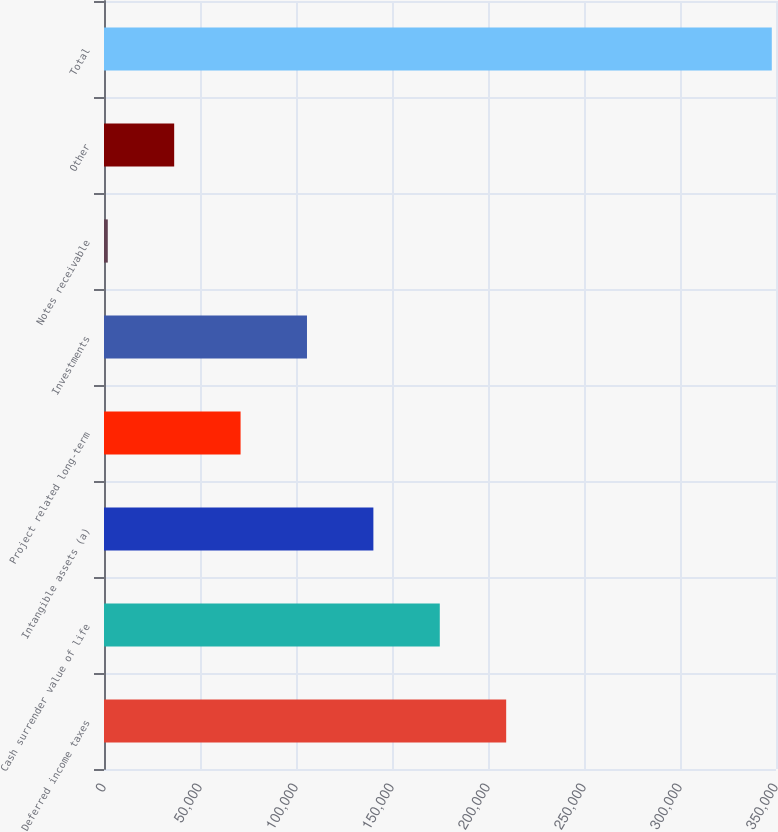Convert chart. <chart><loc_0><loc_0><loc_500><loc_500><bar_chart><fcel>Deferred income taxes<fcel>Cash surrender value of life<fcel>Intangible assets (a)<fcel>Project related long-term<fcel>Investments<fcel>Notes receivable<fcel>Other<fcel>Total<nl><fcel>209470<fcel>174886<fcel>140303<fcel>71136<fcel>105720<fcel>1969<fcel>36552.5<fcel>347804<nl></chart> 